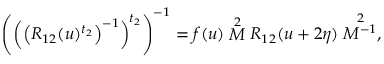<formula> <loc_0><loc_0><loc_500><loc_500>\left ( \left ( \left ( R _ { 1 2 } ( u ) ^ { t _ { 2 } } \right ) ^ { - 1 } \right ) ^ { t _ { 2 } } \right ) ^ { - 1 } = f ( u ) \stackrel { 2 } { M } R _ { 1 2 } ( u + 2 \eta ) \stackrel { 2 } { M ^ { - 1 } } ,</formula> 